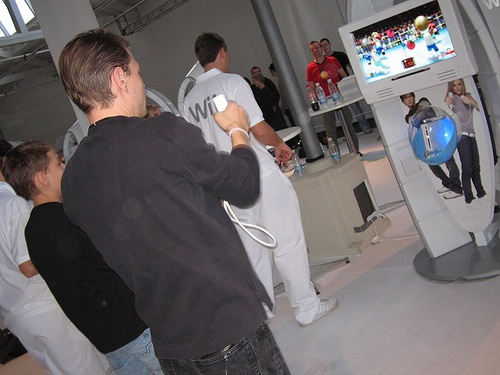Describe the objects in this image and their specific colors. I can see people in white and black tones, people in white, black, gray, and brown tones, people in white, darkgray, and lightgray tones, tv in white, darkgray, black, and lightblue tones, and people in white, darkgray, gray, and black tones in this image. 